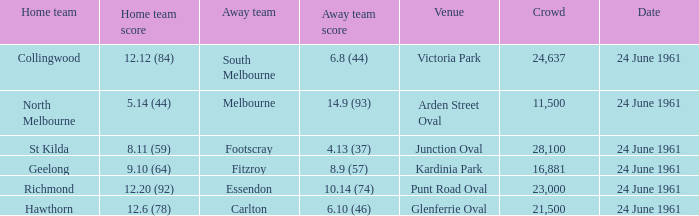I'm looking to parse the entire table for insights. Could you assist me with that? {'header': ['Home team', 'Home team score', 'Away team', 'Away team score', 'Venue', 'Crowd', 'Date'], 'rows': [['Collingwood', '12.12 (84)', 'South Melbourne', '6.8 (44)', 'Victoria Park', '24,637', '24 June 1961'], ['North Melbourne', '5.14 (44)', 'Melbourne', '14.9 (93)', 'Arden Street Oval', '11,500', '24 June 1961'], ['St Kilda', '8.11 (59)', 'Footscray', '4.13 (37)', 'Junction Oval', '28,100', '24 June 1961'], ['Geelong', '9.10 (64)', 'Fitzroy', '8.9 (57)', 'Kardinia Park', '16,881', '24 June 1961'], ['Richmond', '12.20 (92)', 'Essendon', '10.14 (74)', 'Punt Road Oval', '23,000', '24 June 1961'], ['Hawthorn', '12.6 (78)', 'Carlton', '6.10 (46)', 'Glenferrie Oval', '21,500', '24 June 1961']]} 10 (64)? 24 June 1961. 